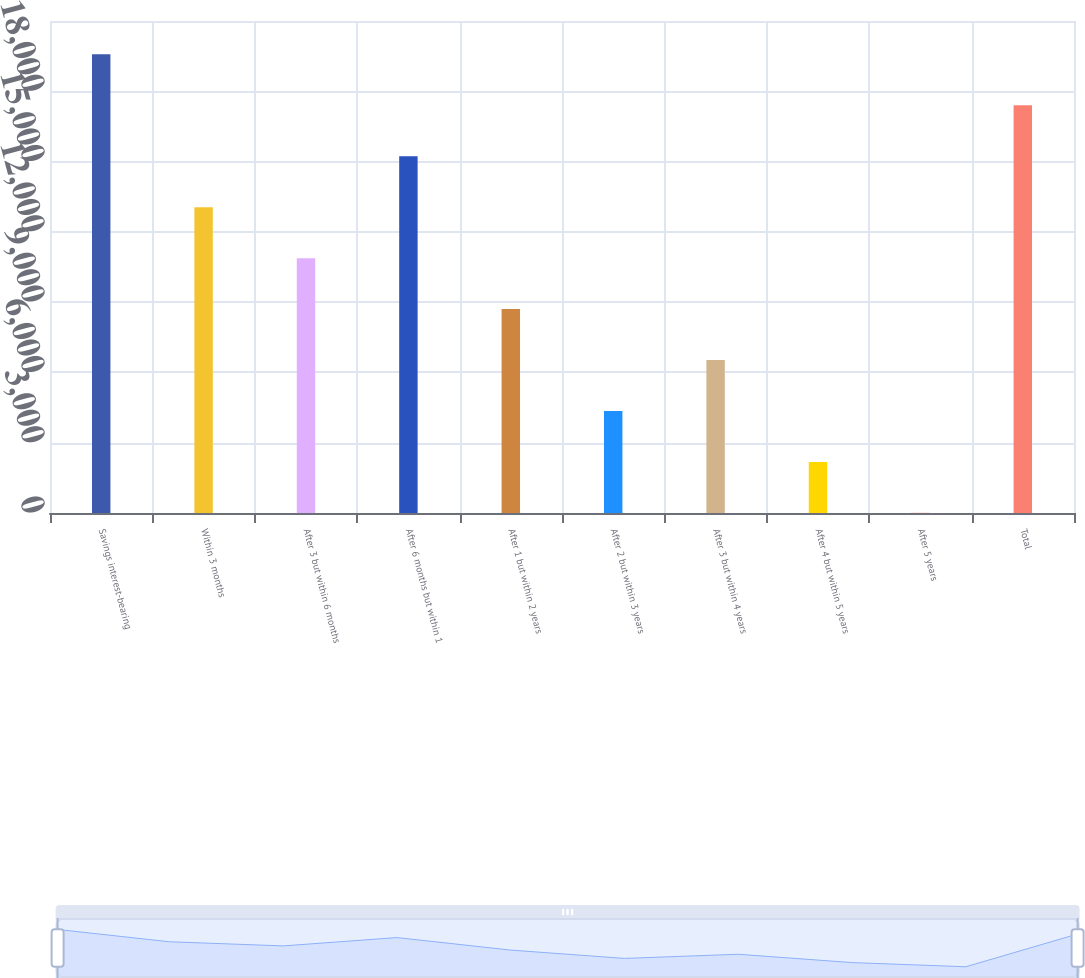Convert chart. <chart><loc_0><loc_0><loc_500><loc_500><bar_chart><fcel>Savings interest-bearing<fcel>Within 3 months<fcel>After 3 but within 6 months<fcel>After 6 months but within 1<fcel>After 1 but within 2 years<fcel>After 2 but within 3 years<fcel>After 3 but within 4 years<fcel>After 4 but within 5 years<fcel>After 5 years<fcel>Total<nl><fcel>19575.9<fcel>13052<fcel>10877.4<fcel>15226.6<fcel>8702.78<fcel>4353.54<fcel>6528.16<fcel>2178.92<fcel>4.3<fcel>17401.3<nl></chart> 